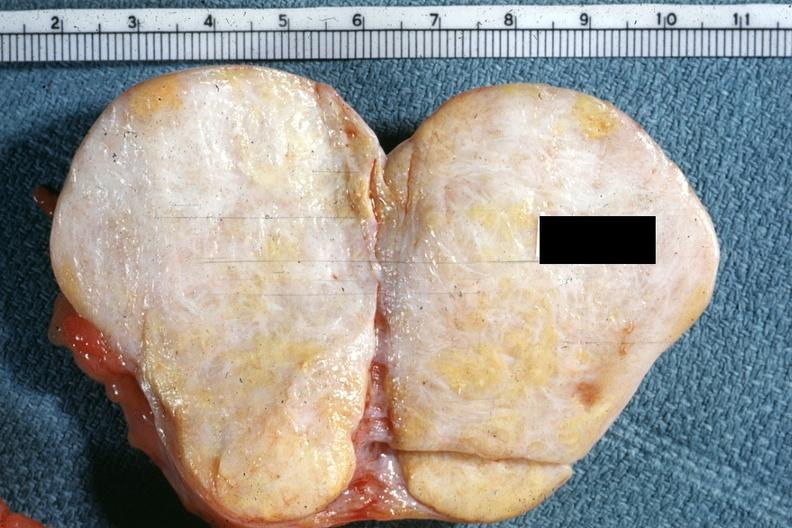s this typical thecoma with yellow foci quite obvious?
Answer the question using a single word or phrase. Yes 